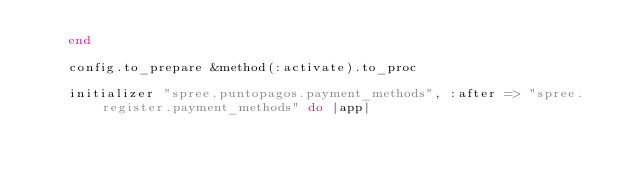<code> <loc_0><loc_0><loc_500><loc_500><_Ruby_>    end

    config.to_prepare &method(:activate).to_proc

    initializer "spree.puntopagos.payment_methods", :after => "spree.register.payment_methods" do |app|</code> 